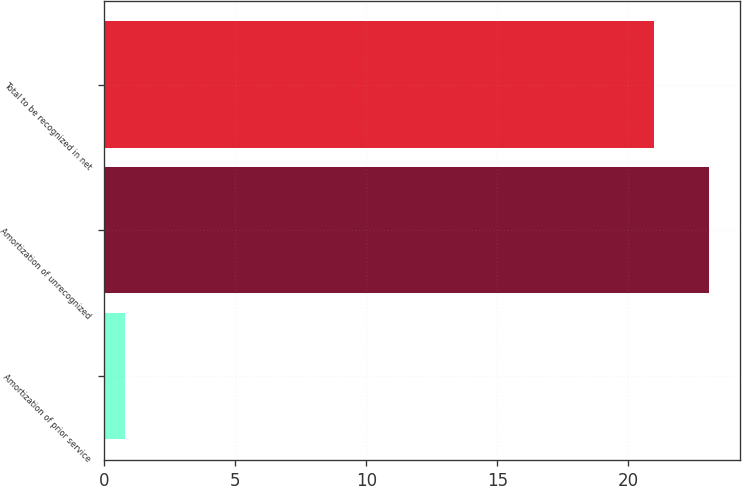Convert chart. <chart><loc_0><loc_0><loc_500><loc_500><bar_chart><fcel>Amortization of prior service<fcel>Amortization of unrecognized<fcel>Total to be recognized in net<nl><fcel>0.8<fcel>23.1<fcel>21<nl></chart> 